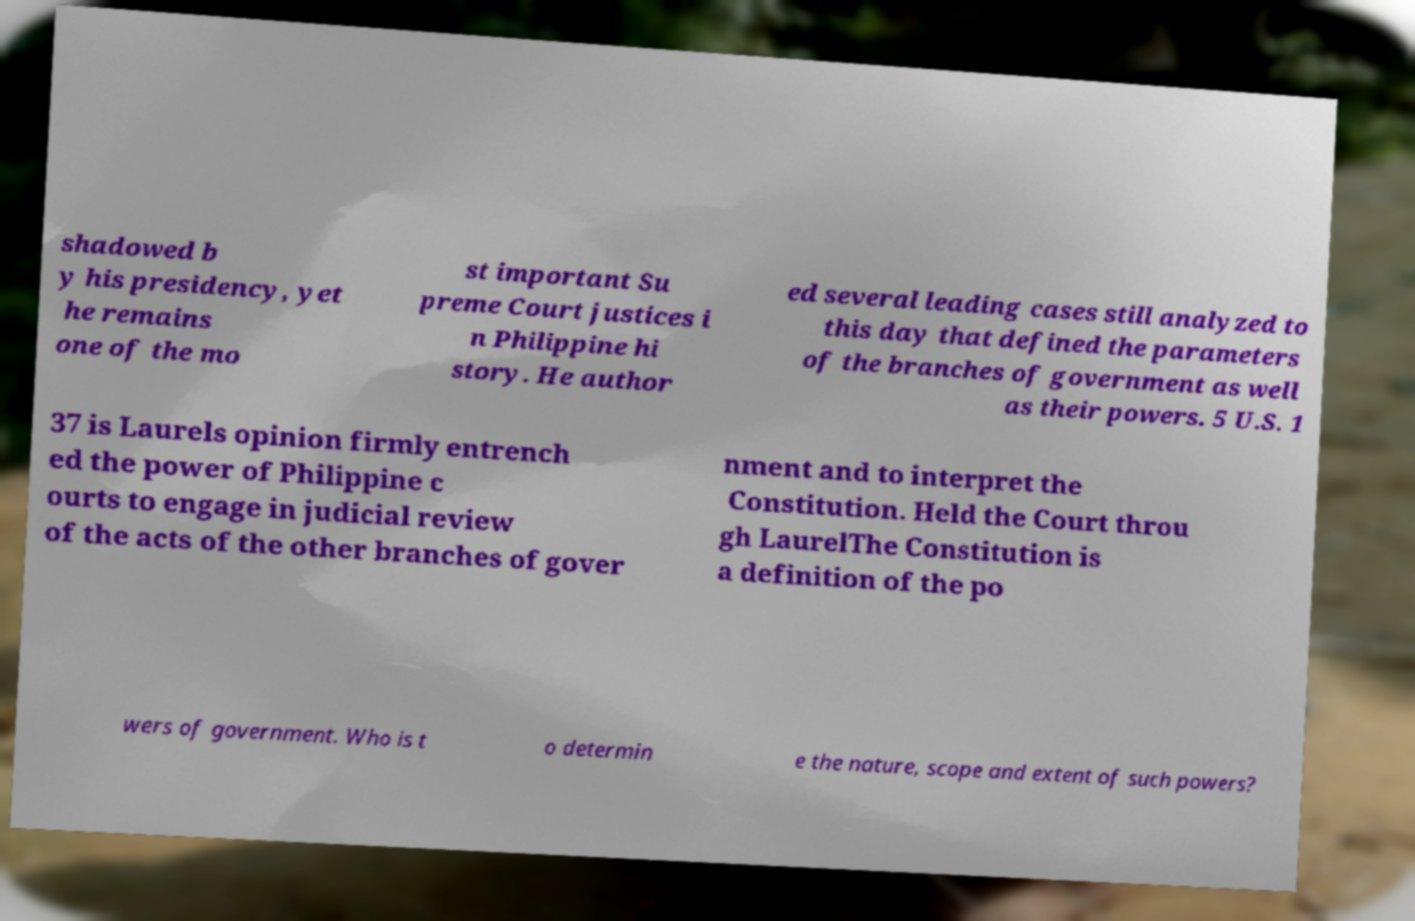Please read and relay the text visible in this image. What does it say? shadowed b y his presidency, yet he remains one of the mo st important Su preme Court justices i n Philippine hi story. He author ed several leading cases still analyzed to this day that defined the parameters of the branches of government as well as their powers. 5 U.S. 1 37 is Laurels opinion firmly entrench ed the power of Philippine c ourts to engage in judicial review of the acts of the other branches of gover nment and to interpret the Constitution. Held the Court throu gh LaurelThe Constitution is a definition of the po wers of government. Who is t o determin e the nature, scope and extent of such powers? 